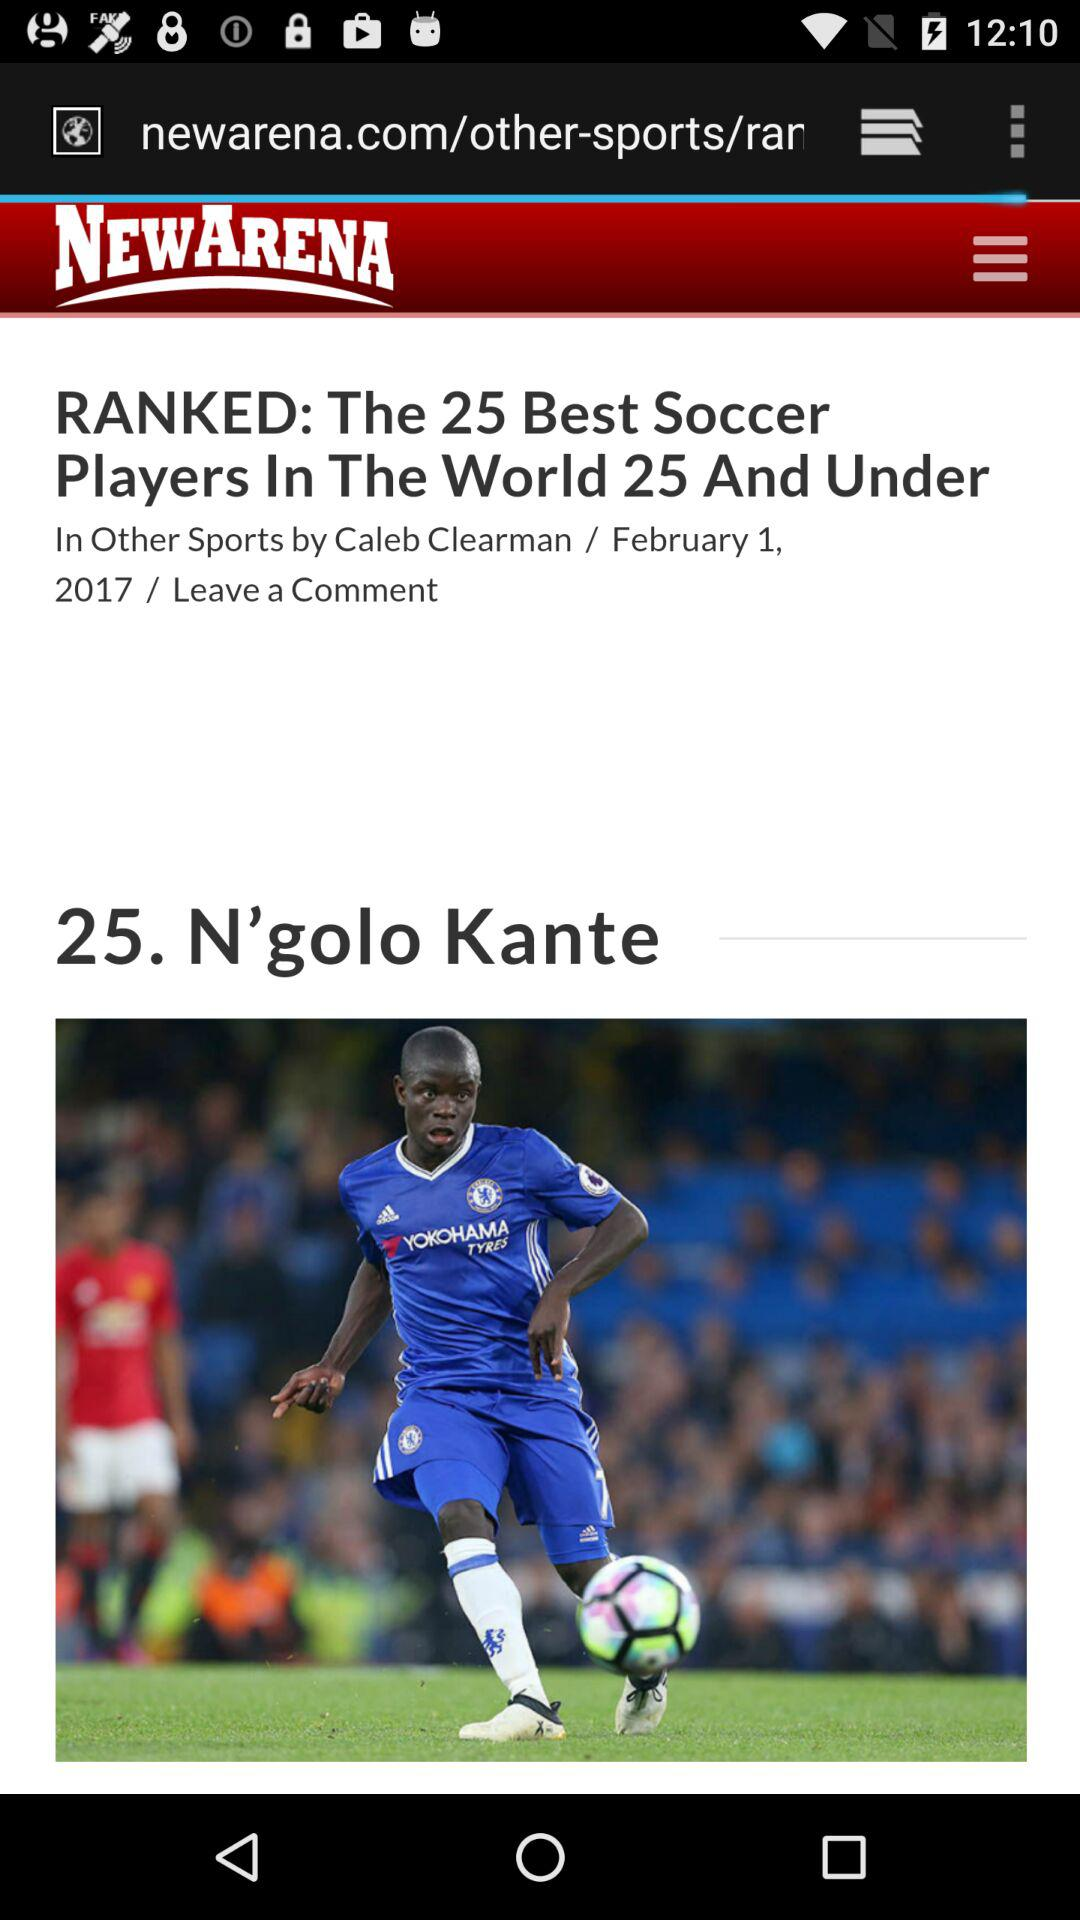What is the name of the soccer player? The soccer player name is N'golo Kante. 